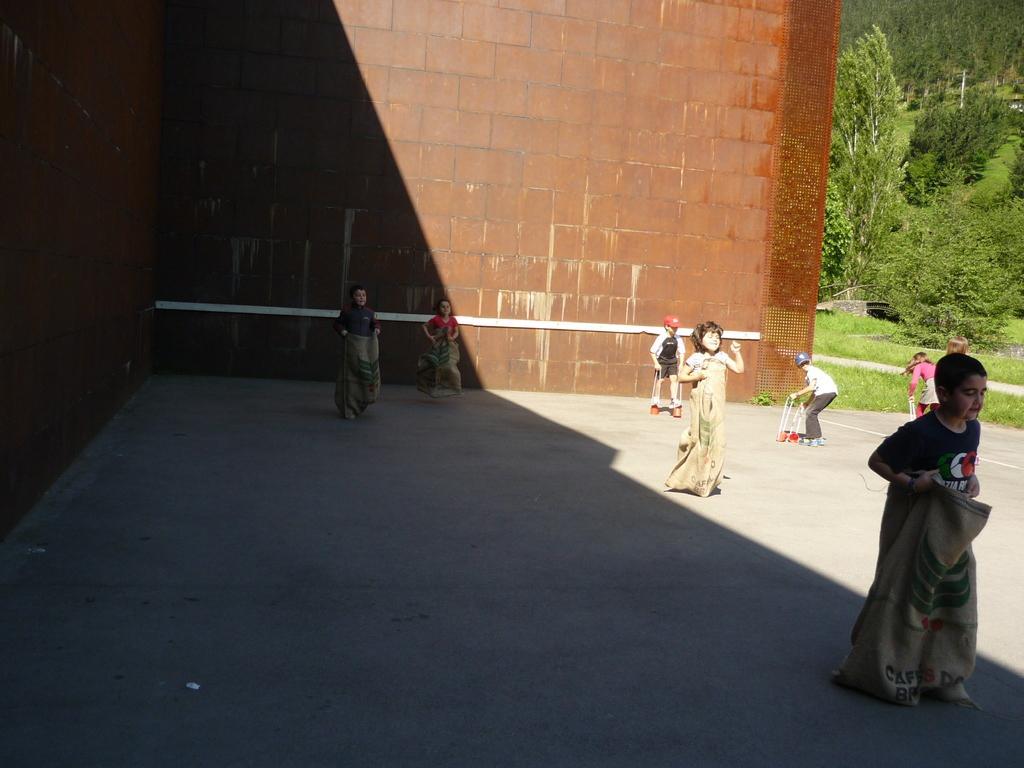Can you describe this image briefly? These kids are holding bags. Background we can see red wall, grass and trees. 